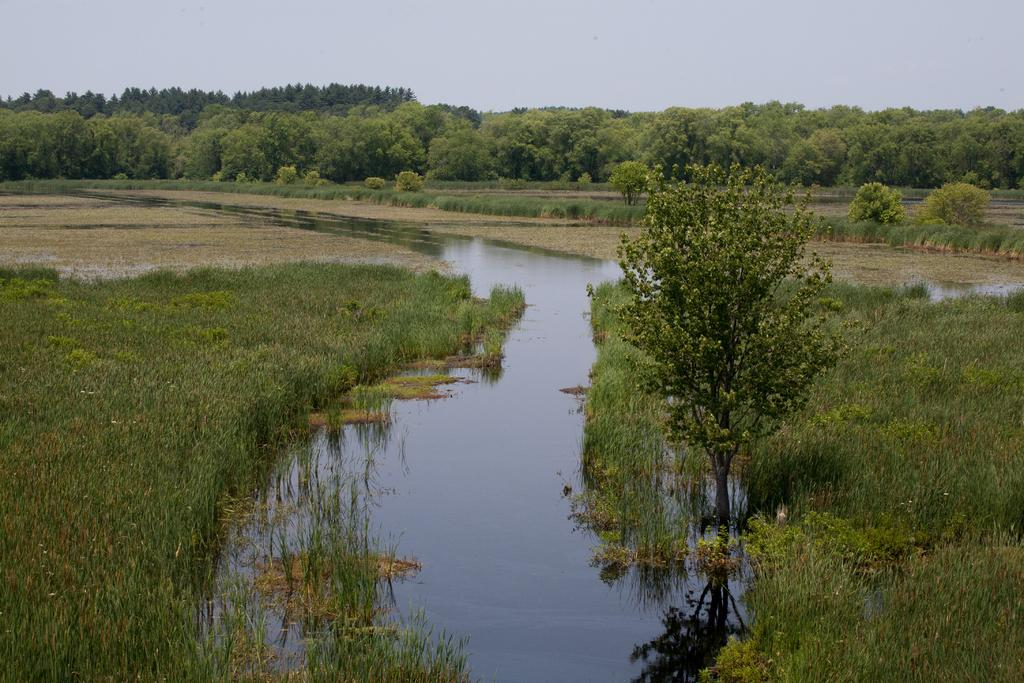What type of vegetation can be seen in the image? There is grass in the image. What else is present in the image besides grass? There is water and trees in the image. What can be seen in the background of the image? The sky is visible in the background of the image. Can you tell me how many yaks are grazing in the grass in the image? There are no yaks present in the image; it features grass, water, and trees. What type of tool is being used by the bat in the image? There is no bat or tool present in the image. 